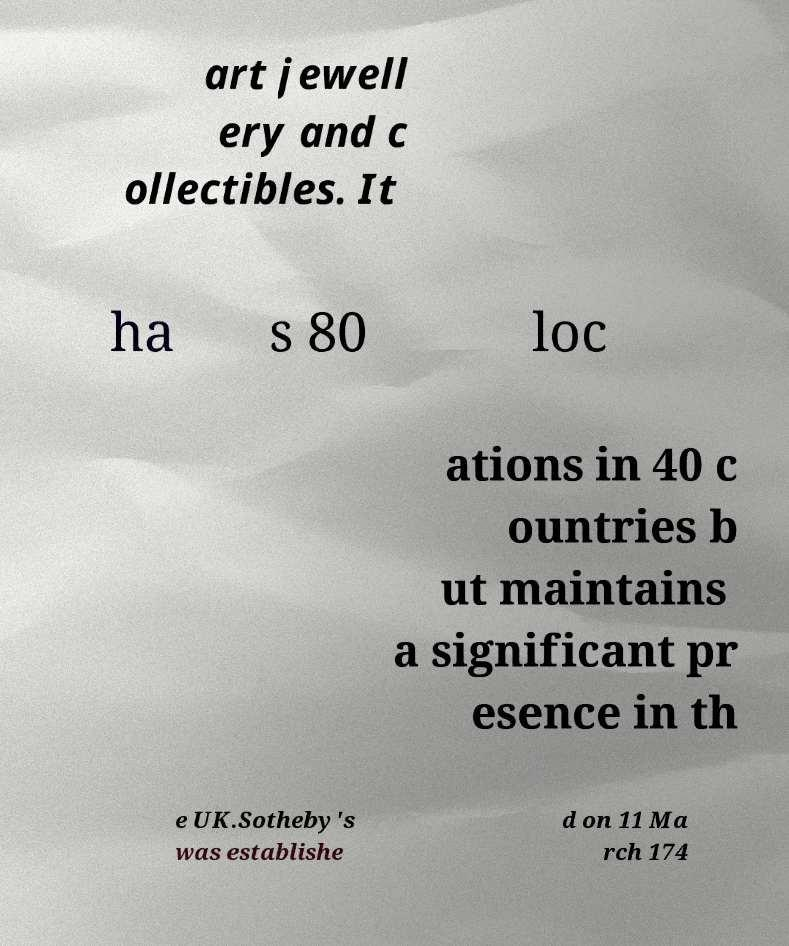Can you accurately transcribe the text from the provided image for me? art jewell ery and c ollectibles. It ha s 80 loc ations in 40 c ountries b ut maintains a significant pr esence in th e UK.Sotheby's was establishe d on 11 Ma rch 174 